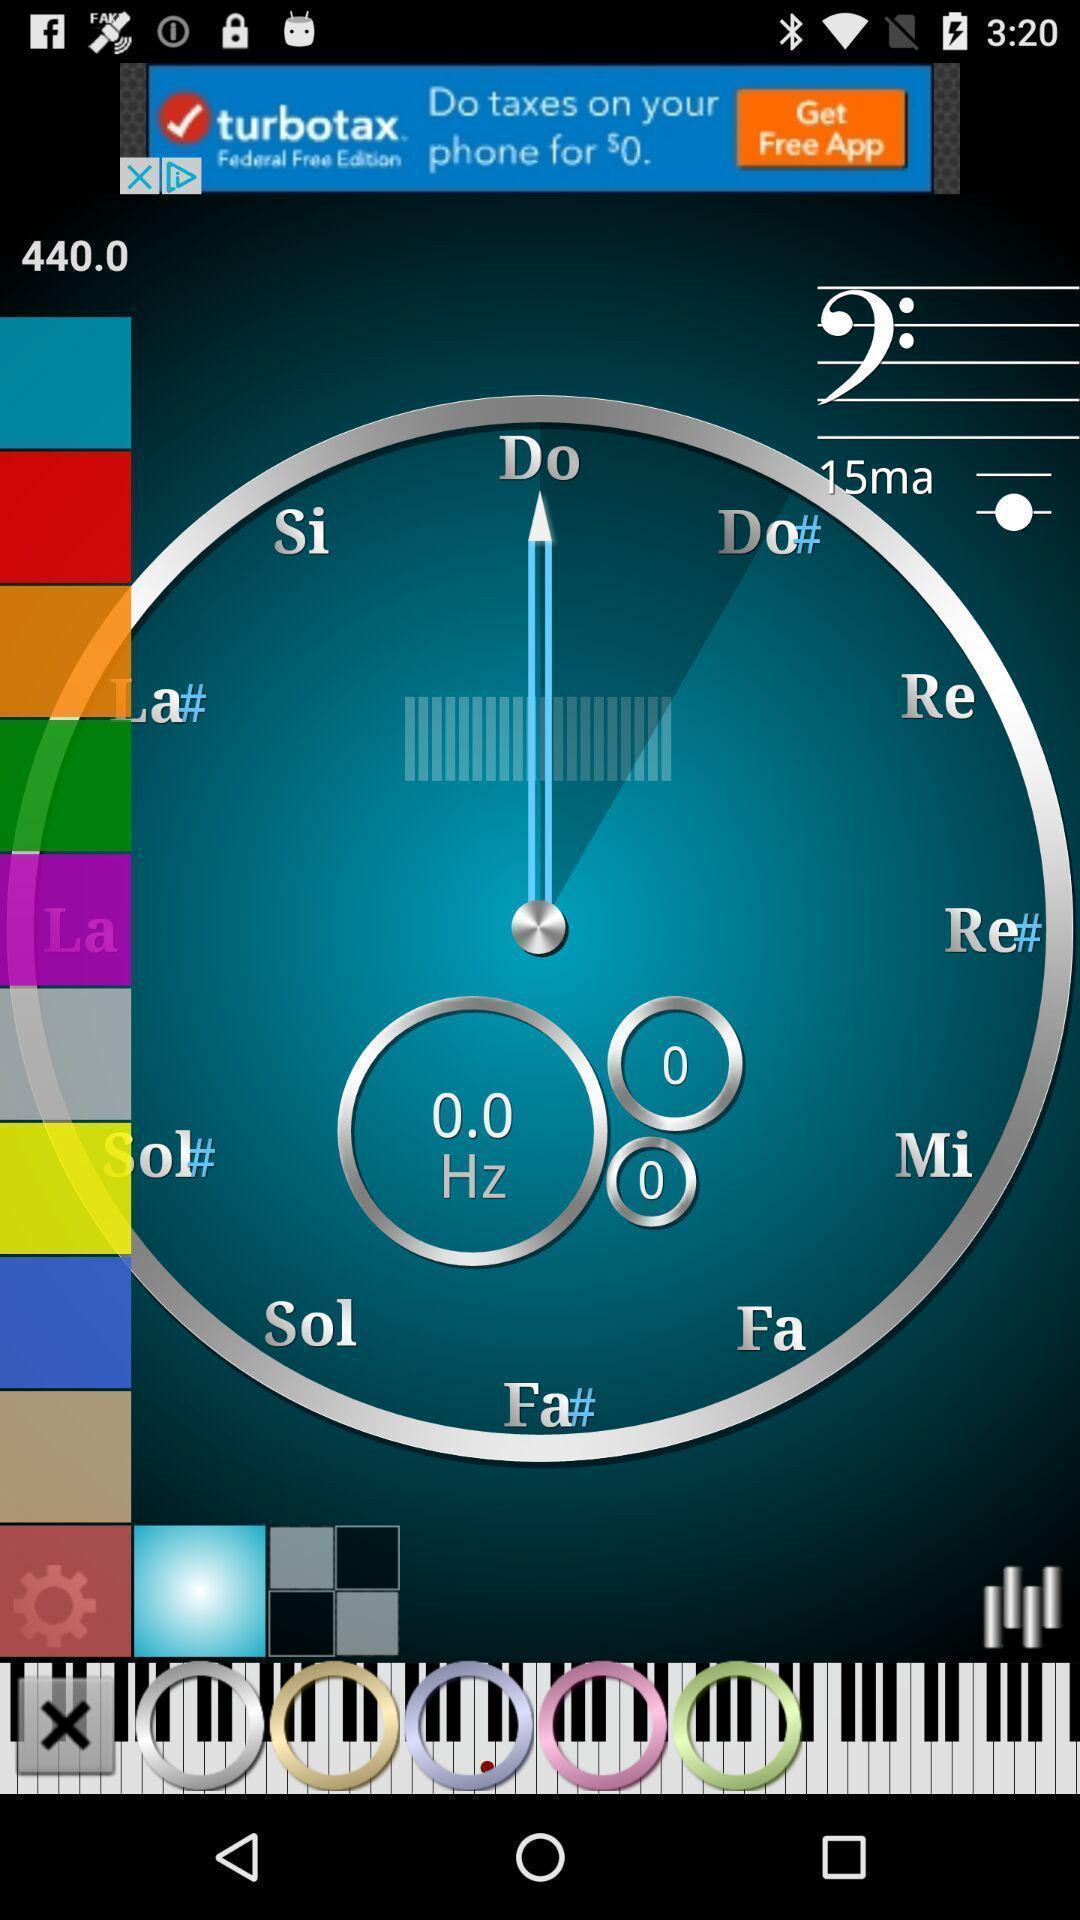Provide a description of this screenshot. Playing piano on a musical instrument learning app. 